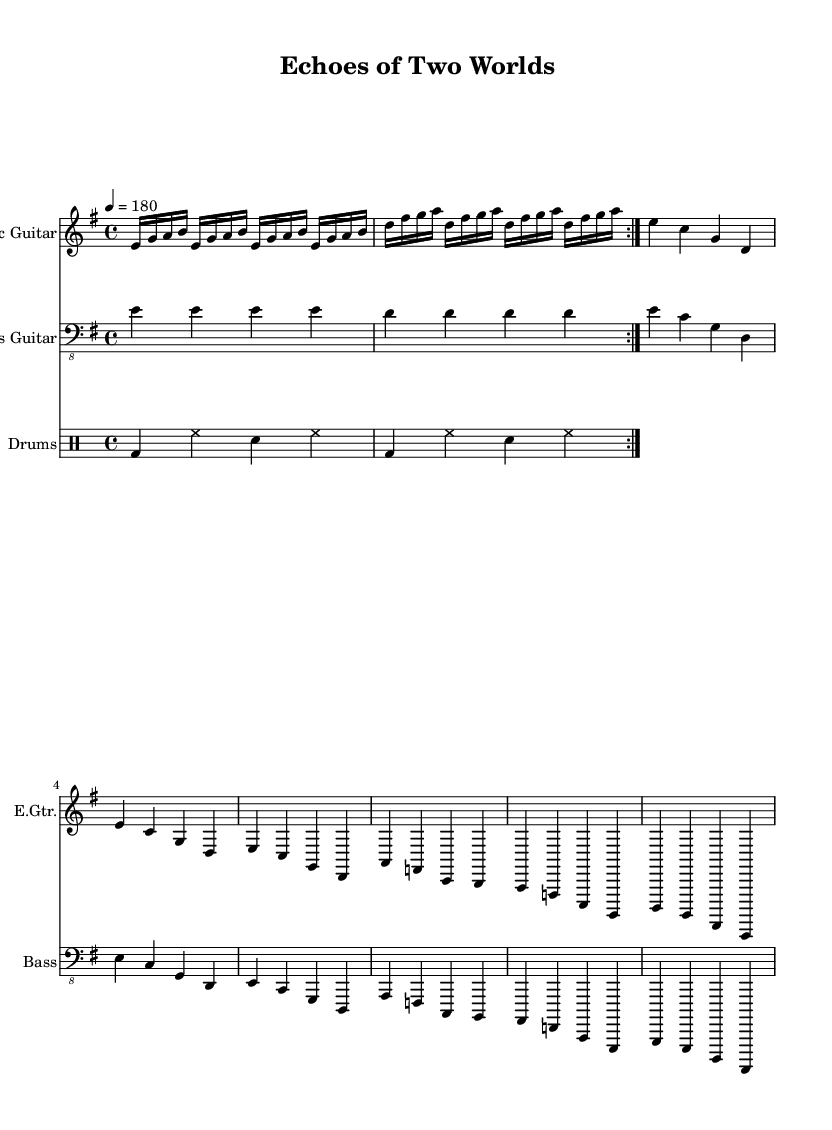What is the key signature of this music? The key signature appears at the beginning of the sheet music, and it indicates E minor, as there is one sharp (F#).
Answer: E minor What is the time signature used in this piece? The time signature is indicated right after the key signature, showing that the music has a 4/4 beat, meaning there are four beats in each measure.
Answer: 4/4 What is the tempo marking for this piece? The tempo marking is found near the beginning of the music, which indicates a speed of 180 beats per minute.
Answer: 180 How many times is the main riff repeated? The main riff is indicated with a repeat sign followed by the text "volta 2," meaning it is played two times.
Answer: 2 What is the first chord in the verse section? The first chord is shown at the start of the verse, and it displays the note E, meaning that the section starts with an E minor chord.
Answer: E minor In the chorus, what is the last note played? The last note in the chorus section is indicated by the single note B, found before transitioning into the bridge.
Answer: B What instrument primarily plays the main riff in this music? The instrument is specified at the top of the staff, which indicates that the electric guitar plays the main riff, as the E.Gtr. transcription signifies that instrument.
Answer: Electric Guitar 